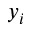Convert formula to latex. <formula><loc_0><loc_0><loc_500><loc_500>y _ { i }</formula> 